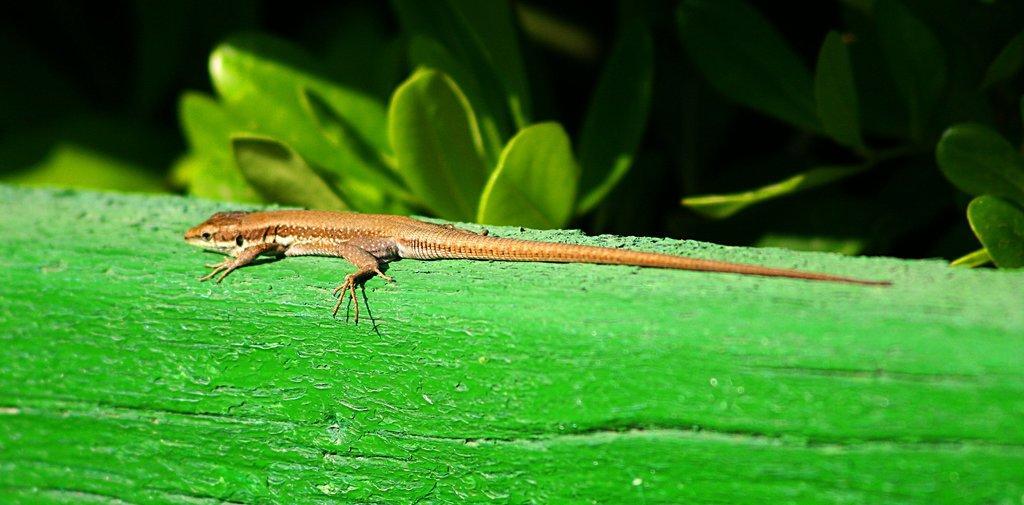Please provide a concise description of this image. In this image, we can see some leaves. There is a lizard on the green surface. 